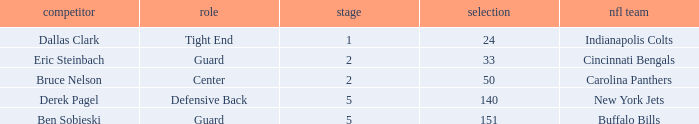What was the latest round that Derek Pagel was selected with a pick higher than 50? 5.0. 